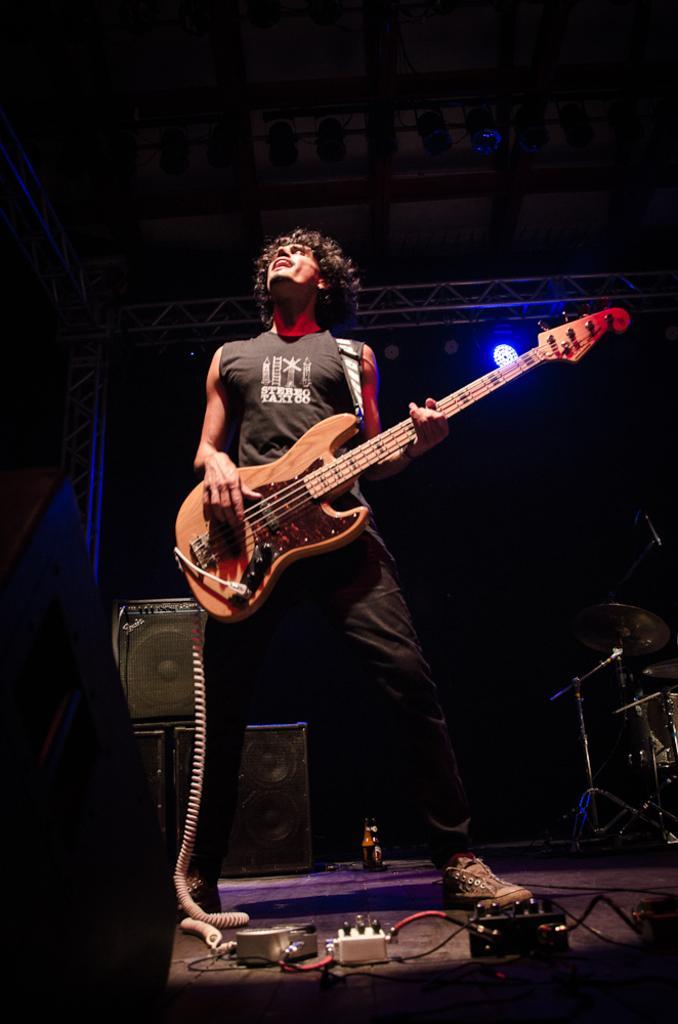Could you give a brief overview of what you see in this image? In this image i can see a person standing and holding a guitar. In the background i can see a speaker, few musical instruments and a light. 